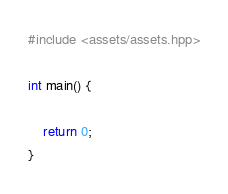Convert code to text. <code><loc_0><loc_0><loc_500><loc_500><_C++_>#include <assets/assets.hpp>

int main() {

    return 0;
}</code> 